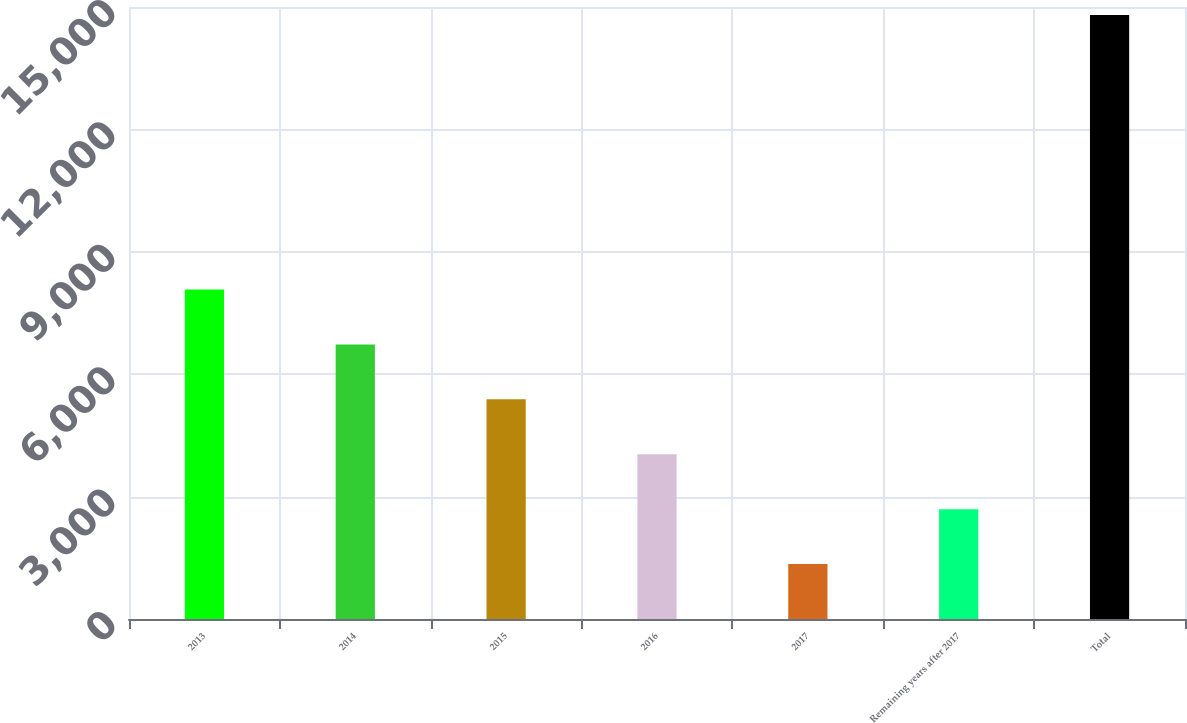Convert chart to OTSL. <chart><loc_0><loc_0><loc_500><loc_500><bar_chart><fcel>2013<fcel>2014<fcel>2015<fcel>2016<fcel>2017<fcel>Remaining years after 2017<fcel>Total<nl><fcel>8076<fcel>6730.2<fcel>5384.4<fcel>4038.6<fcel>1347<fcel>2692.8<fcel>14805<nl></chart> 